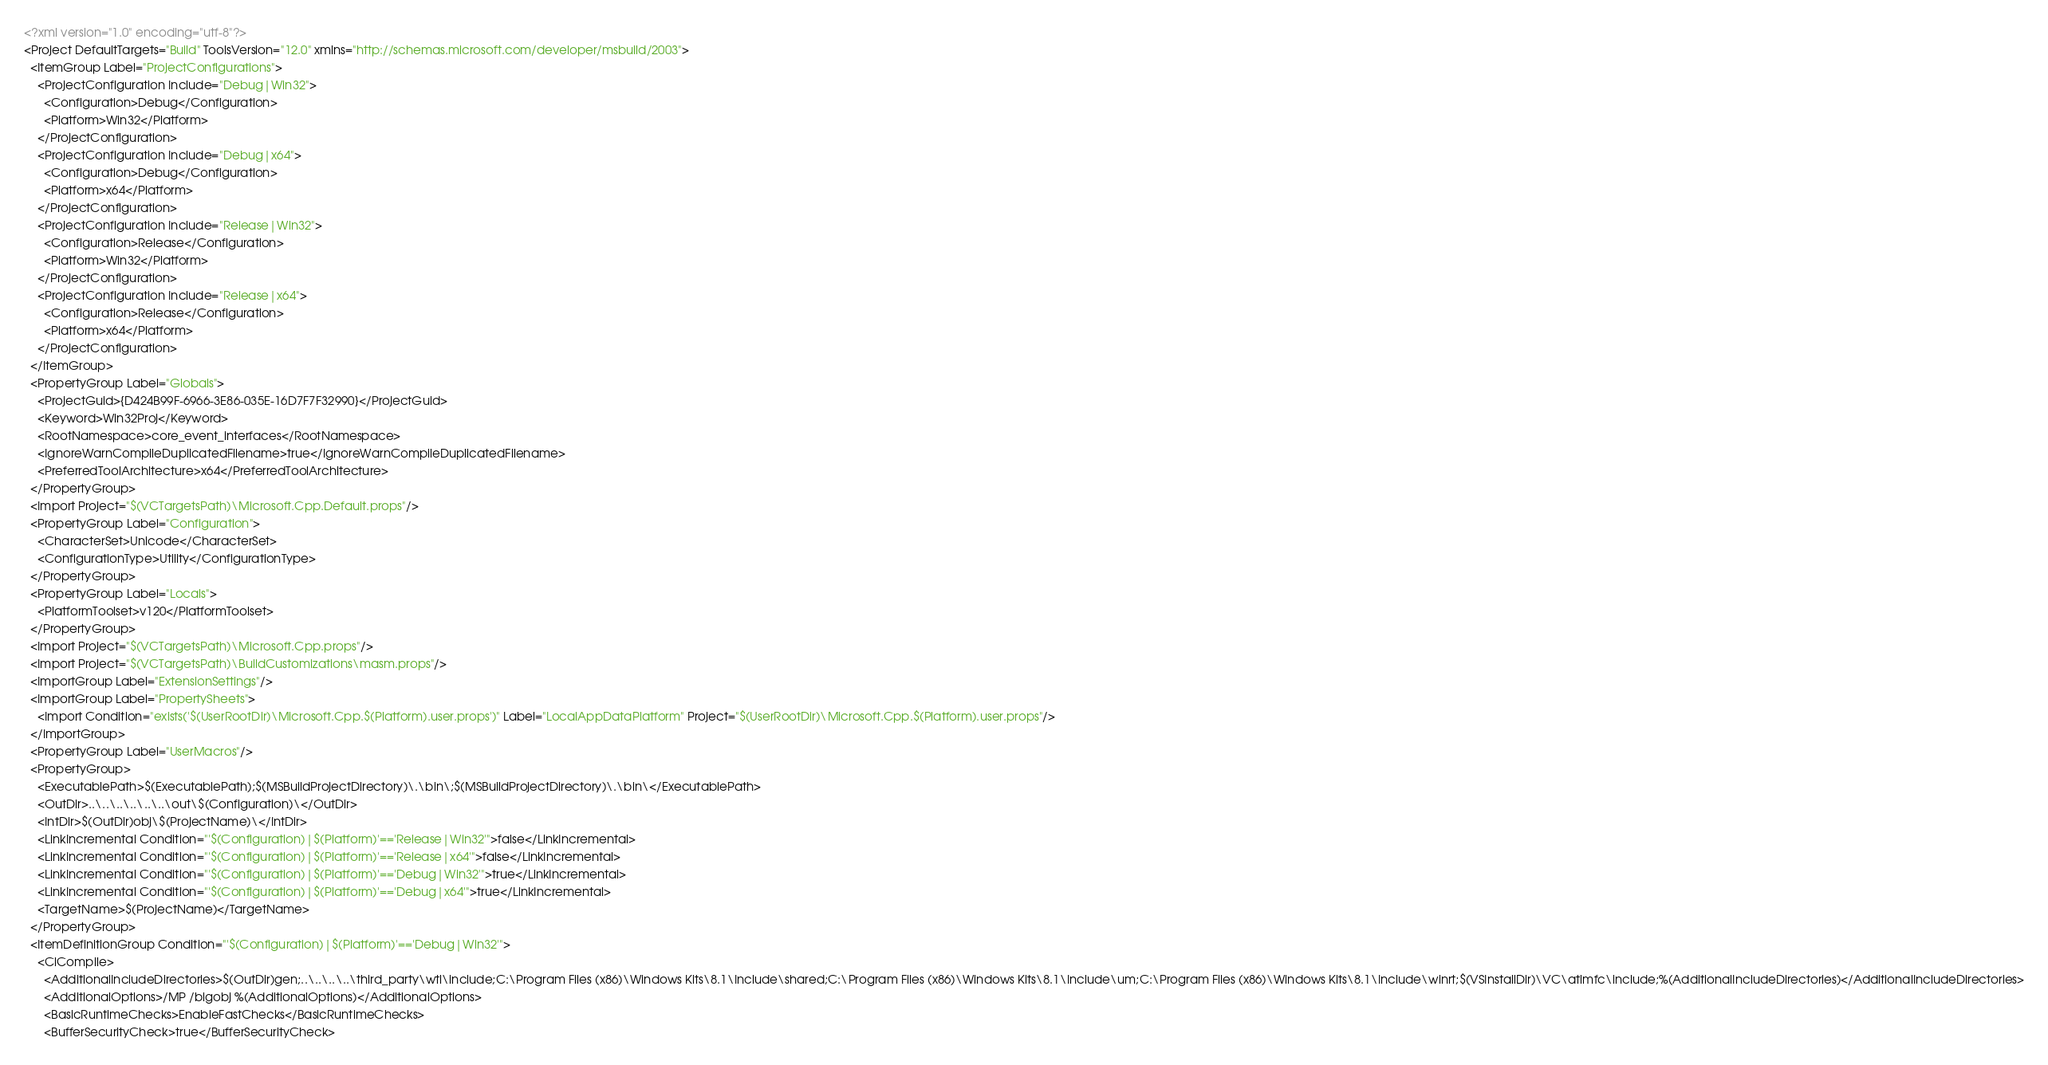Convert code to text. <code><loc_0><loc_0><loc_500><loc_500><_XML_><?xml version="1.0" encoding="utf-8"?>
<Project DefaultTargets="Build" ToolsVersion="12.0" xmlns="http://schemas.microsoft.com/developer/msbuild/2003">
  <ItemGroup Label="ProjectConfigurations">
    <ProjectConfiguration Include="Debug|Win32">
      <Configuration>Debug</Configuration>
      <Platform>Win32</Platform>
    </ProjectConfiguration>
    <ProjectConfiguration Include="Debug|x64">
      <Configuration>Debug</Configuration>
      <Platform>x64</Platform>
    </ProjectConfiguration>
    <ProjectConfiguration Include="Release|Win32">
      <Configuration>Release</Configuration>
      <Platform>Win32</Platform>
    </ProjectConfiguration>
    <ProjectConfiguration Include="Release|x64">
      <Configuration>Release</Configuration>
      <Platform>x64</Platform>
    </ProjectConfiguration>
  </ItemGroup>
  <PropertyGroup Label="Globals">
    <ProjectGuid>{D424B99F-6966-3E86-035E-16D7F7F32990}</ProjectGuid>
    <Keyword>Win32Proj</Keyword>
    <RootNamespace>core_event_interfaces</RootNamespace>
    <IgnoreWarnCompileDuplicatedFilename>true</IgnoreWarnCompileDuplicatedFilename>
    <PreferredToolArchitecture>x64</PreferredToolArchitecture>
  </PropertyGroup>
  <Import Project="$(VCTargetsPath)\Microsoft.Cpp.Default.props"/>
  <PropertyGroup Label="Configuration">
    <CharacterSet>Unicode</CharacterSet>
    <ConfigurationType>Utility</ConfigurationType>
  </PropertyGroup>
  <PropertyGroup Label="Locals">
    <PlatformToolset>v120</PlatformToolset>
  </PropertyGroup>
  <Import Project="$(VCTargetsPath)\Microsoft.Cpp.props"/>
  <Import Project="$(VCTargetsPath)\BuildCustomizations\masm.props"/>
  <ImportGroup Label="ExtensionSettings"/>
  <ImportGroup Label="PropertySheets">
    <Import Condition="exists('$(UserRootDir)\Microsoft.Cpp.$(Platform).user.props')" Label="LocalAppDataPlatform" Project="$(UserRootDir)\Microsoft.Cpp.$(Platform).user.props"/>
  </ImportGroup>
  <PropertyGroup Label="UserMacros"/>
  <PropertyGroup>
    <ExecutablePath>$(ExecutablePath);$(MSBuildProjectDirectory)\.\bin\;$(MSBuildProjectDirectory)\.\bin\</ExecutablePath>
    <OutDir>..\..\..\..\..\..\out\$(Configuration)\</OutDir>
    <IntDir>$(OutDir)obj\$(ProjectName)\</IntDir>
    <LinkIncremental Condition="'$(Configuration)|$(Platform)'=='Release|Win32'">false</LinkIncremental>
    <LinkIncremental Condition="'$(Configuration)|$(Platform)'=='Release|x64'">false</LinkIncremental>
    <LinkIncremental Condition="'$(Configuration)|$(Platform)'=='Debug|Win32'">true</LinkIncremental>
    <LinkIncremental Condition="'$(Configuration)|$(Platform)'=='Debug|x64'">true</LinkIncremental>
    <TargetName>$(ProjectName)</TargetName>
  </PropertyGroup>
  <ItemDefinitionGroup Condition="'$(Configuration)|$(Platform)'=='Debug|Win32'">
    <ClCompile>
      <AdditionalIncludeDirectories>$(OutDir)gen;..\..\..\..\third_party\wtl\include;C:\Program Files (x86)\Windows Kits\8.1\Include\shared;C:\Program Files (x86)\Windows Kits\8.1\Include\um;C:\Program Files (x86)\Windows Kits\8.1\Include\winrt;$(VSInstallDir)\VC\atlmfc\include;%(AdditionalIncludeDirectories)</AdditionalIncludeDirectories>
      <AdditionalOptions>/MP /bigobj %(AdditionalOptions)</AdditionalOptions>
      <BasicRuntimeChecks>EnableFastChecks</BasicRuntimeChecks>
      <BufferSecurityCheck>true</BufferSecurityCheck></code> 